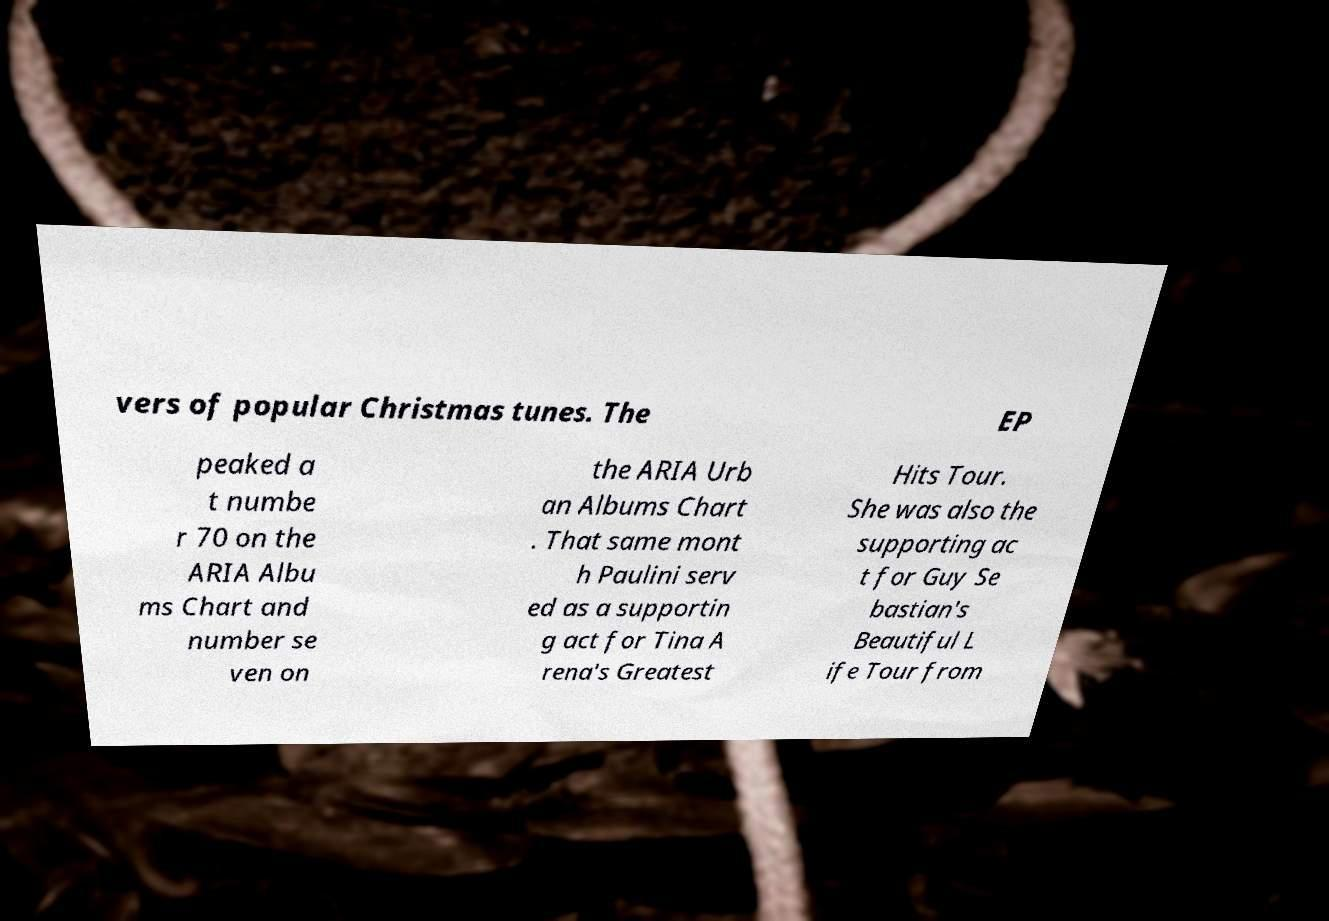Please read and relay the text visible in this image. What does it say? vers of popular Christmas tunes. The EP peaked a t numbe r 70 on the ARIA Albu ms Chart and number se ven on the ARIA Urb an Albums Chart . That same mont h Paulini serv ed as a supportin g act for Tina A rena's Greatest Hits Tour. She was also the supporting ac t for Guy Se bastian's Beautiful L ife Tour from 